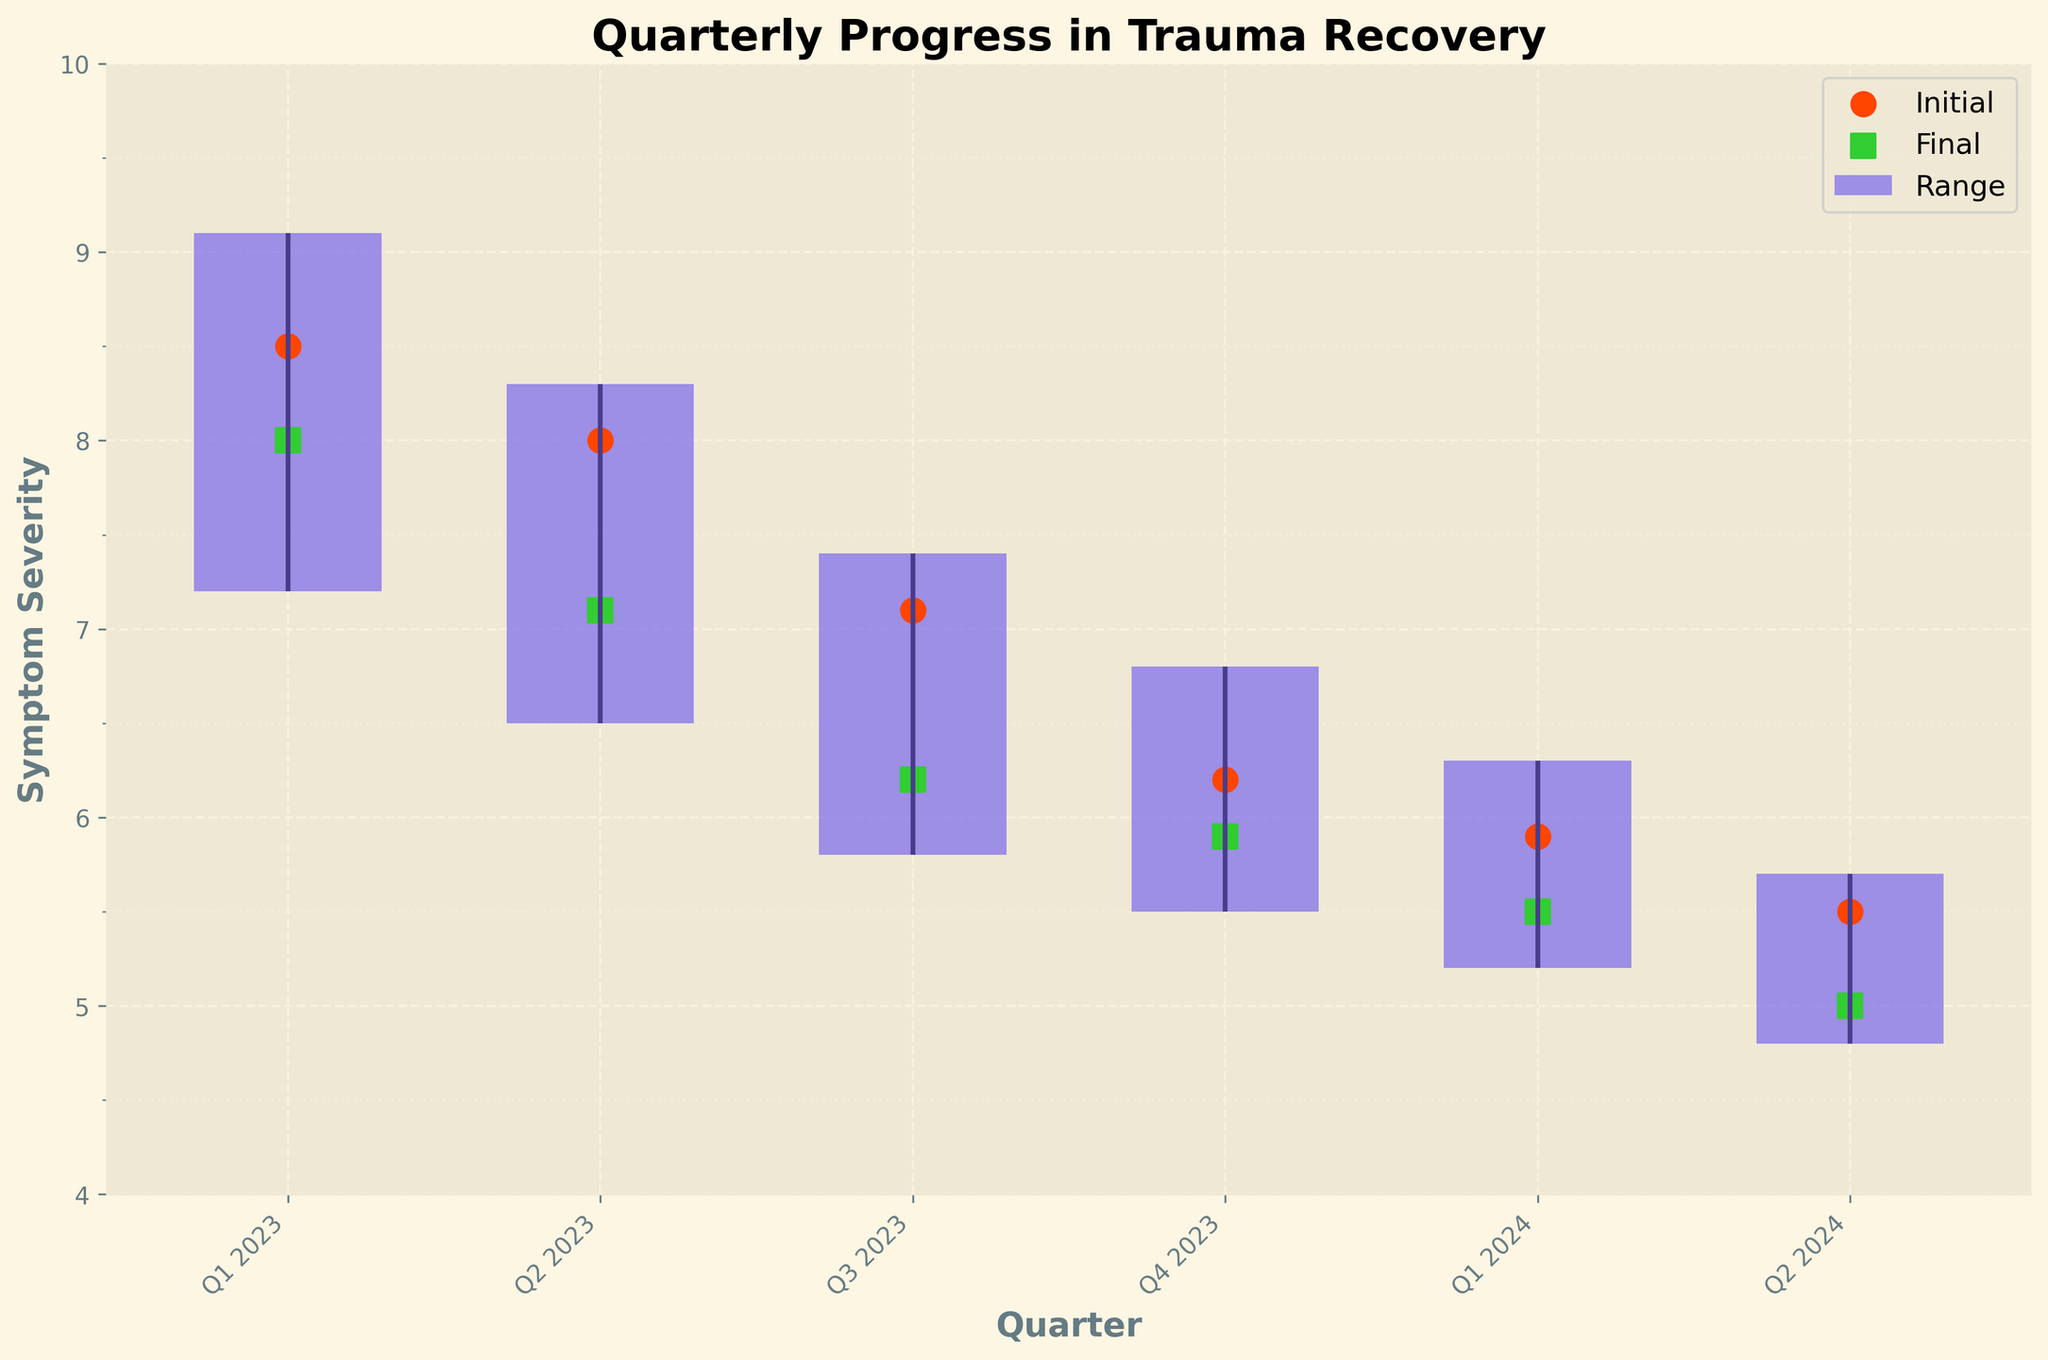What's the overall trend in symptom severity from Q1 2023 to Q2 2024? The chart shows symptom severity decreasing from an initial state of 8.5 in Q1 2023 to a final state of 5.0 in Q2 2024. This indicates a consistent improvement in trauma recovery over the quarters.
Answer: Decreasing What is the highest symptom severity observed, and in which quarter did it occur? The highest symptom severity observed in the figure is 9.1, occurring in Q1 2023. This can be identified by examining the highest data points for each quarter.
Answer: 9.1 in Q1 2023 Which quarter has the smallest range of symptom severity, and what is the range? To identify the smallest range, subtract the lowest value from the highest value for each quarter. Q2 2024 has the smallest range (5.7 - 4.8 = 0.9).
Answer: Q2 2024, range of 0.9 How does the final symptom severity of Q4 2023 compare to the final symptom severity of Q2 2024? The final symptom severity in Q4 2023 is 5.9, and in Q2 2024 it is 5.0. Thus, Q2 2024 shows a lower final symptom severity compared to Q4 2023.
Answer: Lower in Q2 2024 Which quarter shows the most significant improvement from initial to final symptom severity? The improvement can be calculated by subtracting the final value from the initial value for each quarter. Q3 2023 shows the most significant improvement (7.1 - 6.2 = 0.9).
Answer: Q3 2023 What is the trend observed in the "lowest" symptom severity values over the quarters from Q1 2023 to Q2 2024? The "lowest" symptom severity values show a decreasing trend from 7.2 in Q1 2023 to 4.8 in Q2 2024, indicating a general improvement in the lowest observed symptom severity over time.
Answer: Decreasing Compare the best periods in Q1 2023 and Q1 2024. Which one shows better improvement in symptoms? The best periods are the lowest symptom severities: 7.2 in Q1 2023 and 5.2 in Q1 2024. Lower values indicate better improvement, so Q1 2024 shows better improvement.
Answer: Q1 2024 What is the average initial symptom severity across all quarters shown in the chart? Sum up the initial values (8.5 + 8.0 + 7.1 + 6.2 + 5.9 + 5.5) and divide by the number of quarters (6). The average is (41.2 / 6 = 6.87).
Answer: 6.87 How does the severity range in Q2 2023 compare to that in Q4 2023? The range in Q2 2023 is (8.3 - 6.5 = 1.8) and in Q4 2023 it is (6.8 - 5.5 = 1.3). Comparing these, Q2 2023 has a larger range than Q4 2023.
Answer: Larger in Q2 2023 Which quarter ends with a final symptom severity value closest to 6? The final values closest to 6 are in Q3 2023 (6.2) and Q4 2023 (5.9). Between them, Q4 2023 has a final value of 5.9, which is closer to 6.
Answer: Q4 2023 